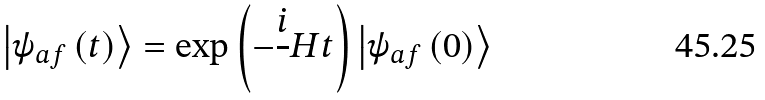Convert formula to latex. <formula><loc_0><loc_0><loc_500><loc_500>\left | \psi _ { a f } \left ( t \right ) \right \rangle = \exp \left ( - \frac { i } { } H t \right ) \left | \psi _ { a f } \left ( 0 \right ) \right \rangle</formula> 